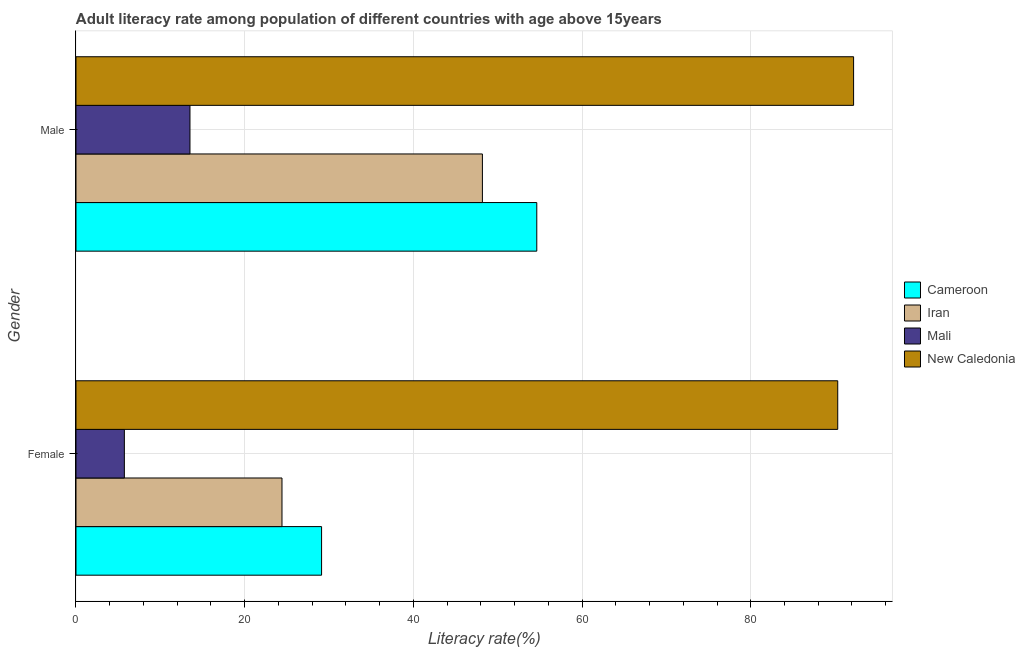How many groups of bars are there?
Give a very brief answer. 2. What is the male adult literacy rate in Cameroon?
Provide a succinct answer. 54.63. Across all countries, what is the maximum male adult literacy rate?
Your answer should be very brief. 92.19. Across all countries, what is the minimum male adult literacy rate?
Ensure brevity in your answer.  13.51. In which country was the female adult literacy rate maximum?
Give a very brief answer. New Caledonia. In which country was the female adult literacy rate minimum?
Provide a succinct answer. Mali. What is the total female adult literacy rate in the graph?
Ensure brevity in your answer.  149.59. What is the difference between the female adult literacy rate in New Caledonia and that in Cameroon?
Offer a very short reply. 61.19. What is the difference between the male adult literacy rate in Iran and the female adult literacy rate in Cameroon?
Provide a succinct answer. 19.07. What is the average female adult literacy rate per country?
Keep it short and to the point. 37.4. What is the difference between the male adult literacy rate and female adult literacy rate in Iran?
Your response must be concise. 23.76. In how many countries, is the female adult literacy rate greater than 32 %?
Keep it short and to the point. 1. What is the ratio of the male adult literacy rate in Cameroon to that in New Caledonia?
Offer a terse response. 0.59. What does the 4th bar from the top in Male represents?
Your response must be concise. Cameroon. What does the 3rd bar from the bottom in Male represents?
Offer a very short reply. Mali. Are all the bars in the graph horizontal?
Keep it short and to the point. Yes. What is the difference between two consecutive major ticks on the X-axis?
Provide a succinct answer. 20. Are the values on the major ticks of X-axis written in scientific E-notation?
Provide a succinct answer. No. Does the graph contain any zero values?
Offer a very short reply. No. Does the graph contain grids?
Give a very brief answer. Yes. How many legend labels are there?
Give a very brief answer. 4. How are the legend labels stacked?
Keep it short and to the point. Vertical. What is the title of the graph?
Your answer should be compact. Adult literacy rate among population of different countries with age above 15years. Does "Dominica" appear as one of the legend labels in the graph?
Keep it short and to the point. No. What is the label or title of the X-axis?
Your response must be concise. Literacy rate(%). What is the label or title of the Y-axis?
Give a very brief answer. Gender. What is the Literacy rate(%) in Cameroon in Female?
Ensure brevity in your answer.  29.12. What is the Literacy rate(%) of Iran in Female?
Your answer should be compact. 24.42. What is the Literacy rate(%) of Mali in Female?
Ensure brevity in your answer.  5.74. What is the Literacy rate(%) of New Caledonia in Female?
Provide a succinct answer. 90.31. What is the Literacy rate(%) in Cameroon in Male?
Offer a terse response. 54.63. What is the Literacy rate(%) in Iran in Male?
Your response must be concise. 48.18. What is the Literacy rate(%) of Mali in Male?
Make the answer very short. 13.51. What is the Literacy rate(%) in New Caledonia in Male?
Provide a succinct answer. 92.19. Across all Gender, what is the maximum Literacy rate(%) of Cameroon?
Your response must be concise. 54.63. Across all Gender, what is the maximum Literacy rate(%) of Iran?
Make the answer very short. 48.18. Across all Gender, what is the maximum Literacy rate(%) in Mali?
Ensure brevity in your answer.  13.51. Across all Gender, what is the maximum Literacy rate(%) of New Caledonia?
Provide a short and direct response. 92.19. Across all Gender, what is the minimum Literacy rate(%) in Cameroon?
Offer a very short reply. 29.12. Across all Gender, what is the minimum Literacy rate(%) of Iran?
Make the answer very short. 24.42. Across all Gender, what is the minimum Literacy rate(%) of Mali?
Give a very brief answer. 5.74. Across all Gender, what is the minimum Literacy rate(%) in New Caledonia?
Ensure brevity in your answer.  90.31. What is the total Literacy rate(%) in Cameroon in the graph?
Offer a terse response. 83.75. What is the total Literacy rate(%) in Iran in the graph?
Provide a succinct answer. 72.61. What is the total Literacy rate(%) of Mali in the graph?
Your answer should be compact. 19.25. What is the total Literacy rate(%) in New Caledonia in the graph?
Keep it short and to the point. 182.5. What is the difference between the Literacy rate(%) in Cameroon in Female and that in Male?
Your answer should be compact. -25.51. What is the difference between the Literacy rate(%) in Iran in Female and that in Male?
Give a very brief answer. -23.76. What is the difference between the Literacy rate(%) in Mali in Female and that in Male?
Give a very brief answer. -7.78. What is the difference between the Literacy rate(%) in New Caledonia in Female and that in Male?
Your answer should be very brief. -1.88. What is the difference between the Literacy rate(%) in Cameroon in Female and the Literacy rate(%) in Iran in Male?
Offer a very short reply. -19.07. What is the difference between the Literacy rate(%) in Cameroon in Female and the Literacy rate(%) in Mali in Male?
Provide a short and direct response. 15.6. What is the difference between the Literacy rate(%) in Cameroon in Female and the Literacy rate(%) in New Caledonia in Male?
Offer a very short reply. -63.07. What is the difference between the Literacy rate(%) in Iran in Female and the Literacy rate(%) in Mali in Male?
Provide a succinct answer. 10.91. What is the difference between the Literacy rate(%) of Iran in Female and the Literacy rate(%) of New Caledonia in Male?
Make the answer very short. -67.77. What is the difference between the Literacy rate(%) in Mali in Female and the Literacy rate(%) in New Caledonia in Male?
Keep it short and to the point. -86.46. What is the average Literacy rate(%) in Cameroon per Gender?
Provide a short and direct response. 41.87. What is the average Literacy rate(%) of Iran per Gender?
Ensure brevity in your answer.  36.3. What is the average Literacy rate(%) of Mali per Gender?
Provide a short and direct response. 9.62. What is the average Literacy rate(%) in New Caledonia per Gender?
Offer a very short reply. 91.25. What is the difference between the Literacy rate(%) of Cameroon and Literacy rate(%) of Iran in Female?
Your answer should be very brief. 4.69. What is the difference between the Literacy rate(%) in Cameroon and Literacy rate(%) in Mali in Female?
Offer a terse response. 23.38. What is the difference between the Literacy rate(%) of Cameroon and Literacy rate(%) of New Caledonia in Female?
Give a very brief answer. -61.19. What is the difference between the Literacy rate(%) of Iran and Literacy rate(%) of Mali in Female?
Offer a very short reply. 18.69. What is the difference between the Literacy rate(%) of Iran and Literacy rate(%) of New Caledonia in Female?
Keep it short and to the point. -65.89. What is the difference between the Literacy rate(%) of Mali and Literacy rate(%) of New Caledonia in Female?
Ensure brevity in your answer.  -84.58. What is the difference between the Literacy rate(%) of Cameroon and Literacy rate(%) of Iran in Male?
Your answer should be compact. 6.45. What is the difference between the Literacy rate(%) in Cameroon and Literacy rate(%) in Mali in Male?
Your answer should be compact. 41.12. What is the difference between the Literacy rate(%) of Cameroon and Literacy rate(%) of New Caledonia in Male?
Your response must be concise. -37.56. What is the difference between the Literacy rate(%) in Iran and Literacy rate(%) in Mali in Male?
Your response must be concise. 34.67. What is the difference between the Literacy rate(%) in Iran and Literacy rate(%) in New Caledonia in Male?
Make the answer very short. -44.01. What is the difference between the Literacy rate(%) of Mali and Literacy rate(%) of New Caledonia in Male?
Provide a short and direct response. -78.68. What is the ratio of the Literacy rate(%) of Cameroon in Female to that in Male?
Offer a terse response. 0.53. What is the ratio of the Literacy rate(%) in Iran in Female to that in Male?
Your answer should be very brief. 0.51. What is the ratio of the Literacy rate(%) in Mali in Female to that in Male?
Offer a terse response. 0.42. What is the ratio of the Literacy rate(%) of New Caledonia in Female to that in Male?
Your answer should be compact. 0.98. What is the difference between the highest and the second highest Literacy rate(%) of Cameroon?
Your response must be concise. 25.51. What is the difference between the highest and the second highest Literacy rate(%) of Iran?
Provide a short and direct response. 23.76. What is the difference between the highest and the second highest Literacy rate(%) in Mali?
Ensure brevity in your answer.  7.78. What is the difference between the highest and the second highest Literacy rate(%) of New Caledonia?
Provide a succinct answer. 1.88. What is the difference between the highest and the lowest Literacy rate(%) in Cameroon?
Make the answer very short. 25.51. What is the difference between the highest and the lowest Literacy rate(%) of Iran?
Ensure brevity in your answer.  23.76. What is the difference between the highest and the lowest Literacy rate(%) in Mali?
Give a very brief answer. 7.78. What is the difference between the highest and the lowest Literacy rate(%) of New Caledonia?
Make the answer very short. 1.88. 